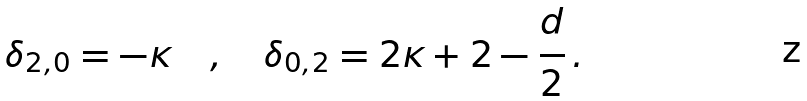Convert formula to latex. <formula><loc_0><loc_0><loc_500><loc_500>\delta _ { 2 , 0 } = - \kappa \quad , \quad \delta _ { 0 , 2 } = 2 \kappa + 2 - \frac { d } { 2 } \, .</formula> 